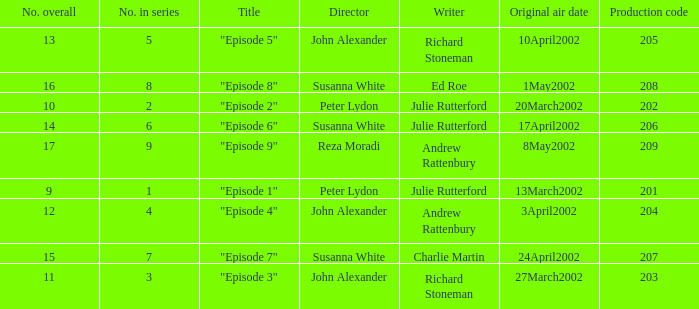When 15 is the number overall what is the original air date? 24April2002. 